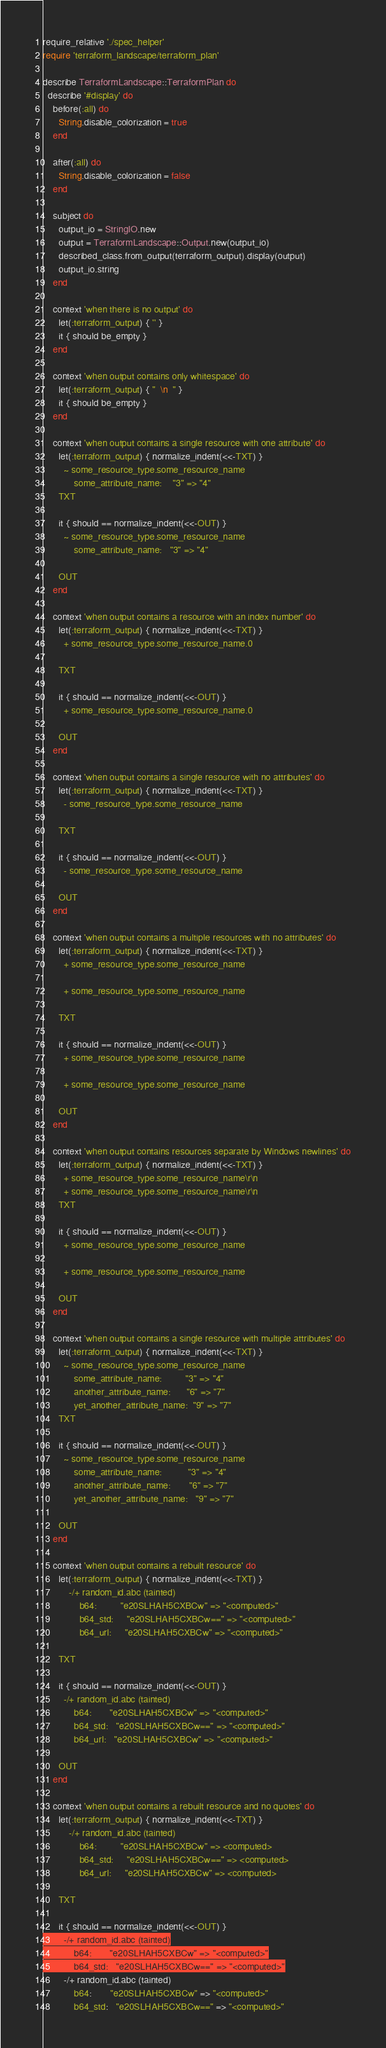Convert code to text. <code><loc_0><loc_0><loc_500><loc_500><_Ruby_>require_relative './spec_helper'
require 'terraform_landscape/terraform_plan'

describe TerraformLandscape::TerraformPlan do
  describe '#display' do
    before(:all) do
      String.disable_colorization = true
    end

    after(:all) do
      String.disable_colorization = false
    end

    subject do
      output_io = StringIO.new
      output = TerraformLandscape::Output.new(output_io)
      described_class.from_output(terraform_output).display(output)
      output_io.string
    end

    context 'when there is no output' do
      let(:terraform_output) { '' }
      it { should be_empty }
    end

    context 'when output contains only whitespace' do
      let(:terraform_output) { "  \n  " }
      it { should be_empty }
    end

    context 'when output contains a single resource with one attribute' do
      let(:terraform_output) { normalize_indent(<<-TXT) }
        ~ some_resource_type.some_resource_name
            some_attribute_name:    "3" => "4"
      TXT

      it { should == normalize_indent(<<-OUT) }
        ~ some_resource_type.some_resource_name
            some_attribute_name:   "3" => "4"

      OUT
    end

    context 'when output contains a resource with an index number' do
      let(:terraform_output) { normalize_indent(<<-TXT) }
        + some_resource_type.some_resource_name.0

      TXT

      it { should == normalize_indent(<<-OUT) }
        + some_resource_type.some_resource_name.0

      OUT
    end

    context 'when output contains a single resource with no attributes' do
      let(:terraform_output) { normalize_indent(<<-TXT) }
        - some_resource_type.some_resource_name

      TXT

      it { should == normalize_indent(<<-OUT) }
        - some_resource_type.some_resource_name

      OUT
    end

    context 'when output contains a multiple resources with no attributes' do
      let(:terraform_output) { normalize_indent(<<-TXT) }
        + some_resource_type.some_resource_name

        + some_resource_type.some_resource_name

      TXT

      it { should == normalize_indent(<<-OUT) }
        + some_resource_type.some_resource_name

        + some_resource_type.some_resource_name

      OUT
    end

    context 'when output contains resources separate by Windows newlines' do
      let(:terraform_output) { normalize_indent(<<-TXT) }
        + some_resource_type.some_resource_name\r\n
        + some_resource_type.some_resource_name\r\n
      TXT

      it { should == normalize_indent(<<-OUT) }
        + some_resource_type.some_resource_name

        + some_resource_type.some_resource_name

      OUT
    end

    context 'when output contains a single resource with multiple attributes' do
      let(:terraform_output) { normalize_indent(<<-TXT) }
        ~ some_resource_type.some_resource_name
            some_attribute_name:         "3" => "4"
            another_attribute_name:      "6" => "7"
            yet_another_attribute_name:  "9" => "7"
      TXT

      it { should == normalize_indent(<<-OUT) }
        ~ some_resource_type.some_resource_name
            some_attribute_name:          "3" => "4"
            another_attribute_name:       "6" => "7"
            yet_another_attribute_name:   "9" => "7"

      OUT
    end

    context 'when output contains a rebuilt resource' do
      let(:terraform_output) { normalize_indent(<<-TXT) }
          -/+ random_id.abc (tainted)
              b64:         "e20SLHAH5CXBCw" => "<computed>"
              b64_std:     "e20SLHAH5CXBCw==" => "<computed>"
              b64_url:     "e20SLHAH5CXBCw" => "<computed>"

      TXT

      it { should == normalize_indent(<<-OUT) }
        -/+ random_id.abc (tainted)
            b64:       "e20SLHAH5CXBCw" => "<computed>"
            b64_std:   "e20SLHAH5CXBCw==" => "<computed>"
            b64_url:   "e20SLHAH5CXBCw" => "<computed>"

      OUT
    end

    context 'when output contains a rebuilt resource and no quotes' do
      let(:terraform_output) { normalize_indent(<<-TXT) }
          -/+ random_id.abc (tainted)
              b64:         "e20SLHAH5CXBCw" => <computed>
              b64_std:     "e20SLHAH5CXBCw==" => <computed>
              b64_url:     "e20SLHAH5CXBCw" => <computed>

      TXT

      it { should == normalize_indent(<<-OUT) }
        -/+ random_id.abc (tainted)
            b64:       "e20SLHAH5CXBCw" => "<computed>"
            b64_std:   "e20SLHAH5CXBCw==" => "<computed>"</code> 